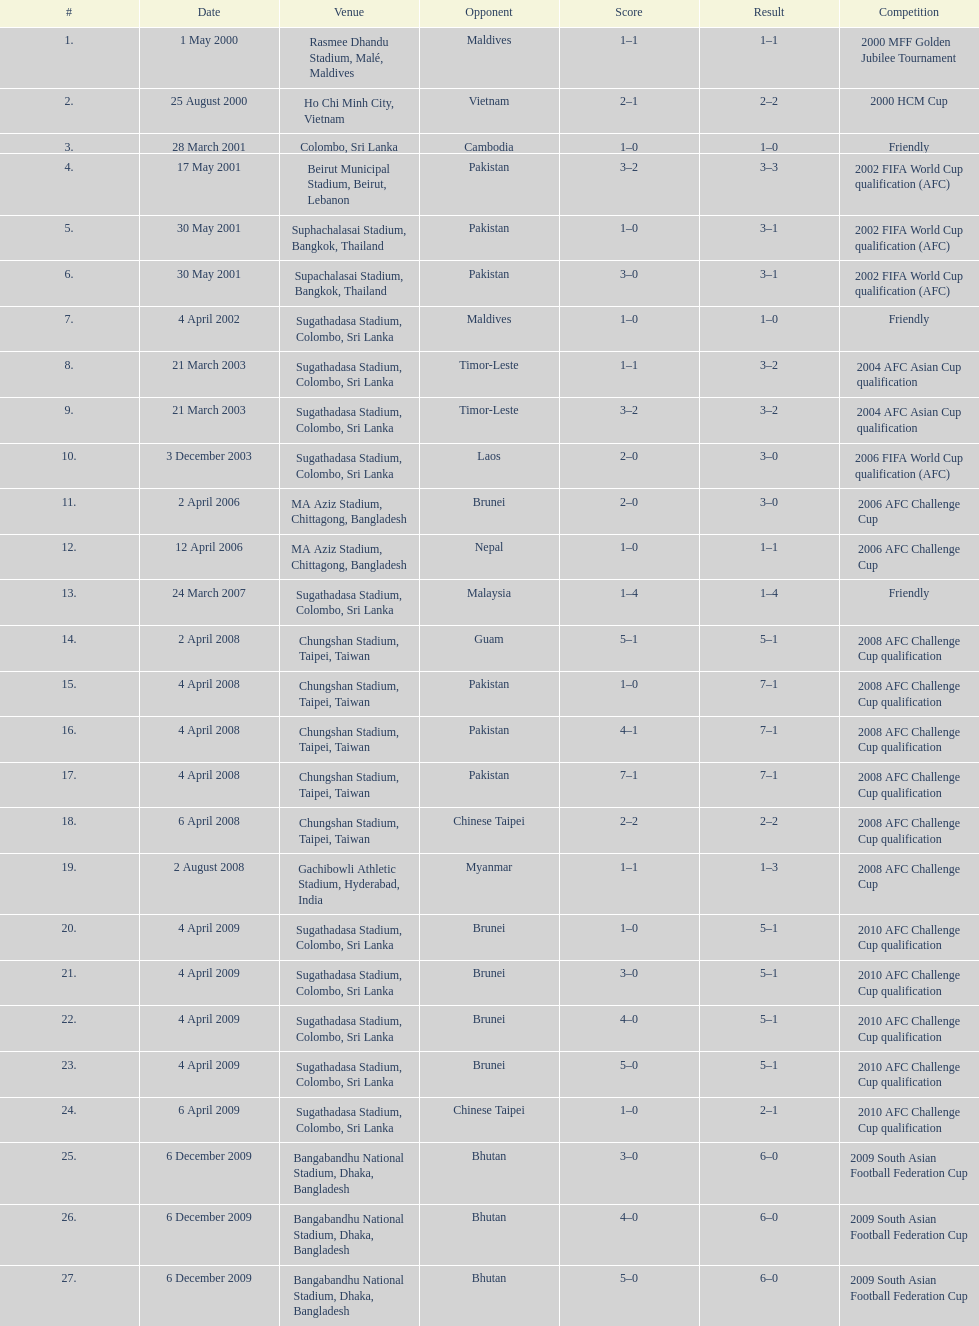What was the overall goal count in the sri lanka vs. malaysia match on march 24, 2007? 5. 